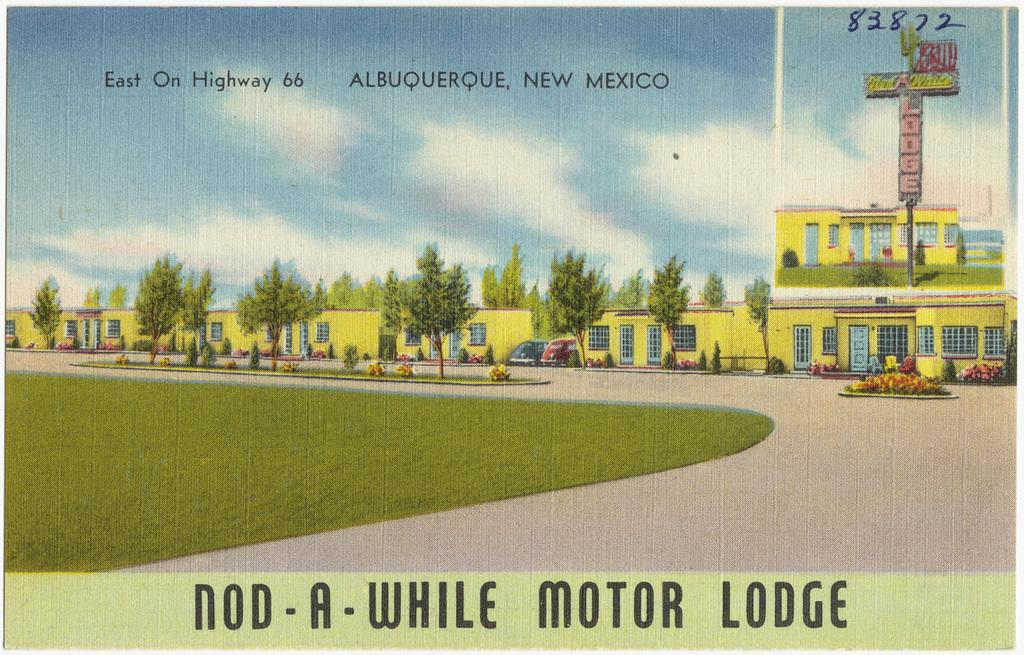<image>
Present a compact description of the photo's key features. Postcard showing a row of yellow bulidings and "Nod-A-While Motor Lodge" near the bottom. 